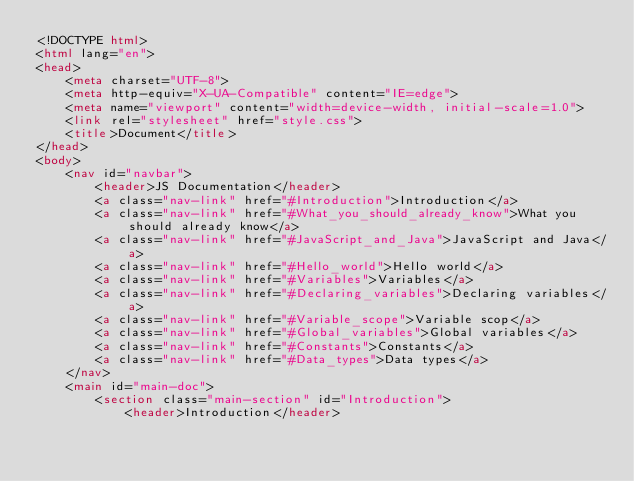Convert code to text. <code><loc_0><loc_0><loc_500><loc_500><_HTML_><!DOCTYPE html>
<html lang="en">
<head>
    <meta charset="UTF-8">
    <meta http-equiv="X-UA-Compatible" content="IE=edge">
    <meta name="viewport" content="width=device-width, initial-scale=1.0">
    <link rel="stylesheet" href="style.css">
    <title>Document</title>
</head>
<body>
    <nav id="navbar">
        <header>JS Documentation</header>
        <a class="nav-link" href="#Introduction">Introduction</a>
        <a class="nav-link" href="#What_you_should_already_know">What you should already know</a>
        <a class="nav-link" href="#JavaScript_and_Java">JavaScript and Java</a>
        <a class="nav-link" href="#Hello_world">Hello world</a>
        <a class="nav-link" href="#Variables">Variables</a>
        <a class="nav-link" href="#Declaring_variables">Declaring variables</a>
        <a class="nav-link" href="#Variable_scope">Variable scop</a>
        <a class="nav-link" href="#Global_variables">Global variables</a>
        <a class="nav-link" href="#Constants">Constants</a>
        <a class="nav-link" href="#Data_types">Data types</a>
    </nav>
    <main id="main-doc">
        <section class="main-section" id="Introduction">
            <header>Introduction</header></code> 